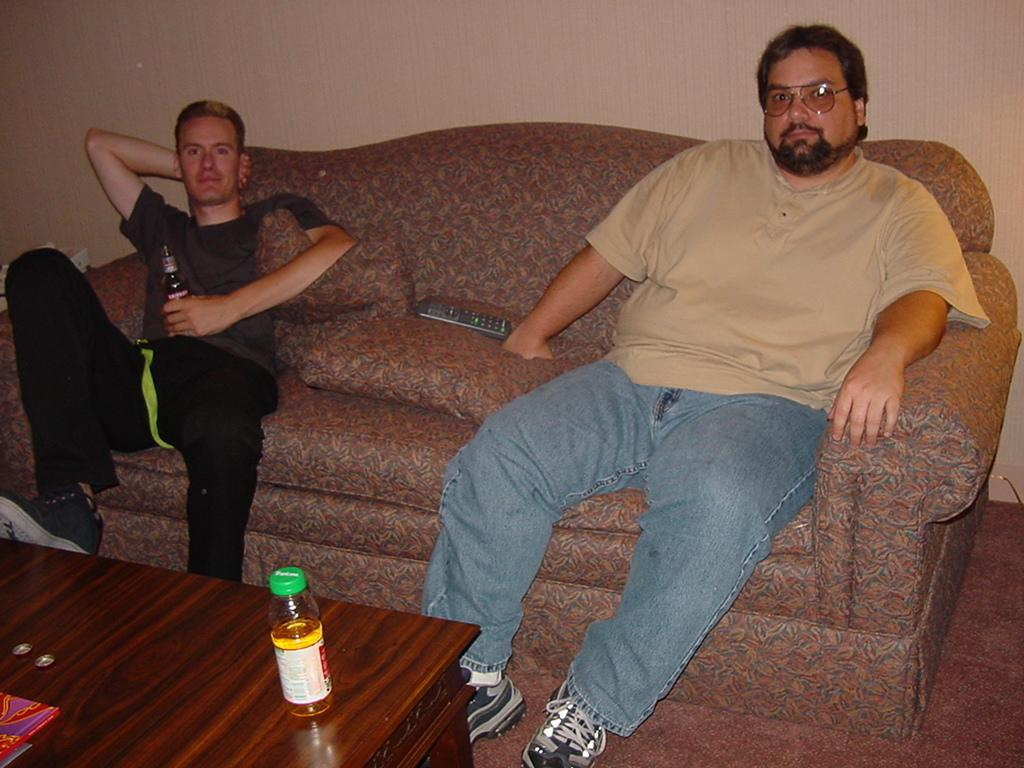How many persons are in the image? There are two persons in the image. What are the persons doing in the image? The persons are sitting on a couch. What other objects can be seen in the image? There is a table, a bottle, and a remote in the image. Can you tell me how many basketballs are visible in the image? There are no basketballs present in the image. What type of war is depicted in the image? There is no depiction of war in the image; it features two persons sitting on a couch. 